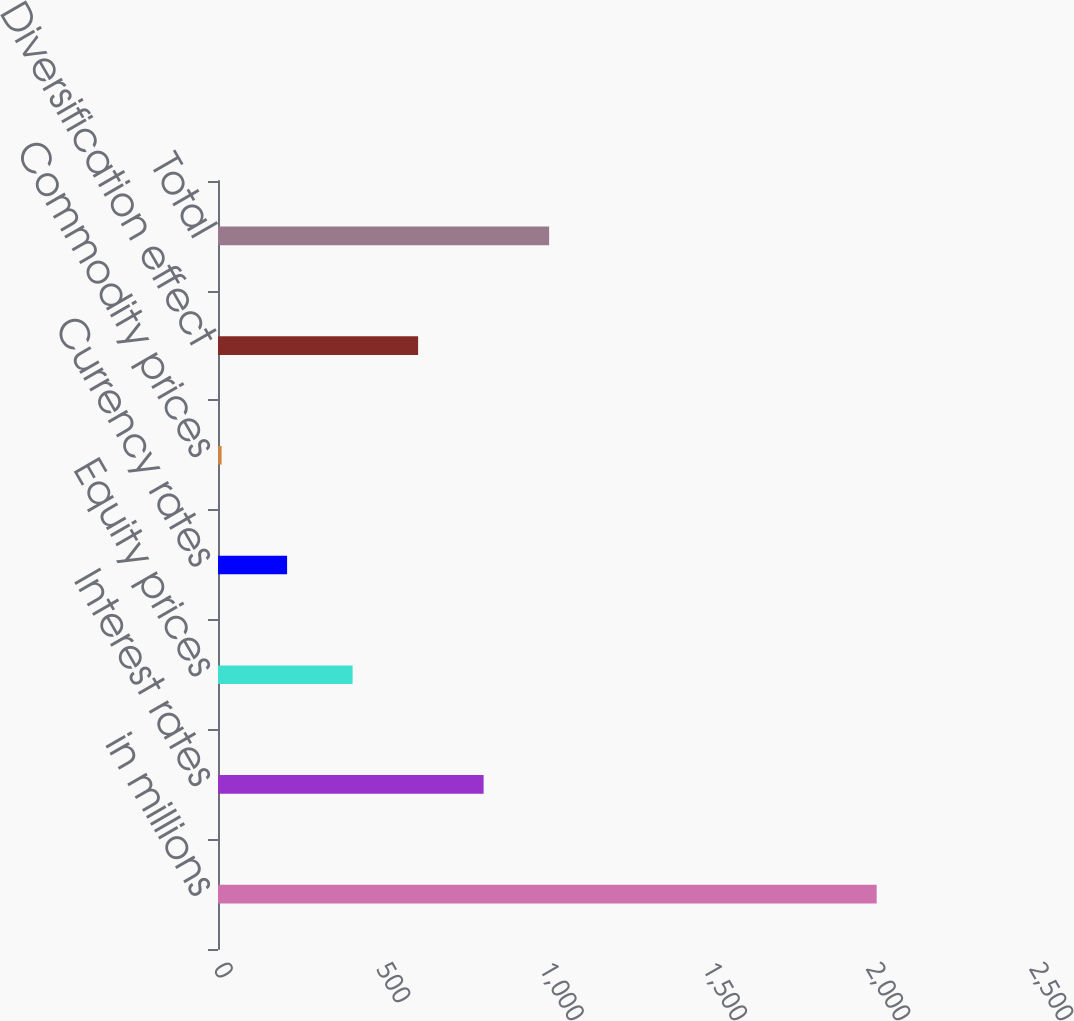<chart> <loc_0><loc_0><loc_500><loc_500><bar_chart><fcel>in millions<fcel>Interest rates<fcel>Equity prices<fcel>Currency rates<fcel>Commodity prices<fcel>Diversification effect<fcel>Total<nl><fcel>2018<fcel>813.8<fcel>412.4<fcel>211.7<fcel>11<fcel>613.1<fcel>1014.5<nl></chart> 